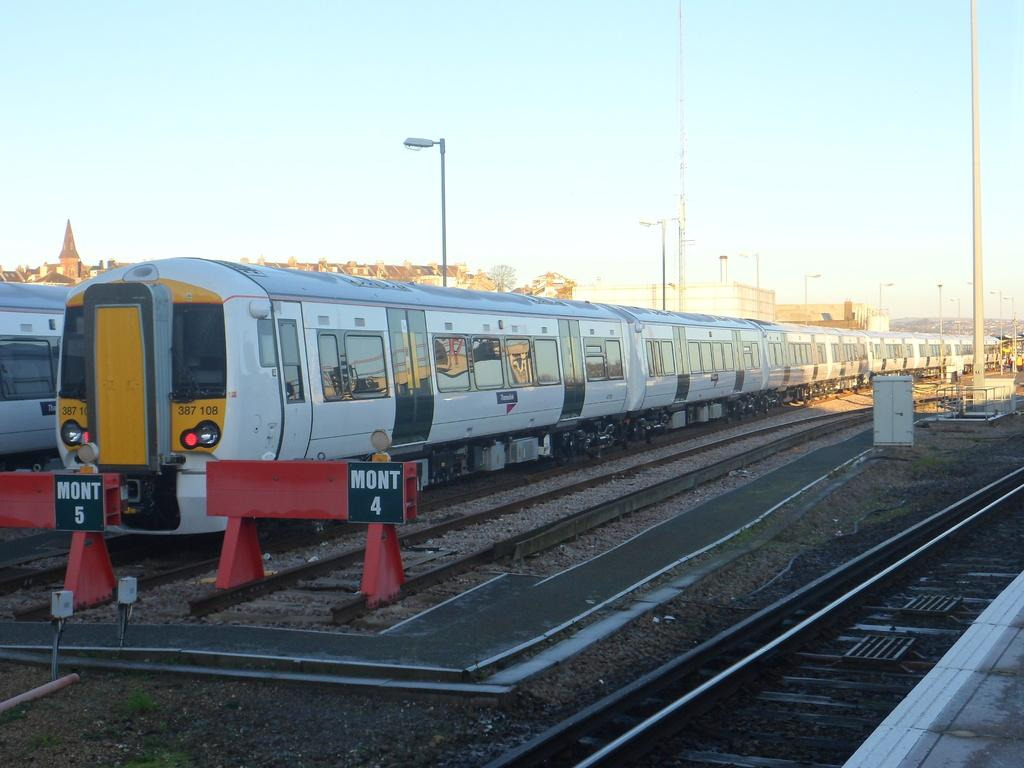What can be seen running along the ground in the image? There are train tracks in the image. What is on the train tracks in the image? There are trains on the tracks. What structures are located beside the train tracks? There are poles beside the train tracks. What can be seen in the distance in the image? There are houses in the background of the image. What is visible above the train tracks and houses in the image? The sky is visible in the image. What type of bread can be seen joining the two train tracks together in the image? There is no bread present in the image, and bread is not used to join train tracks together. 